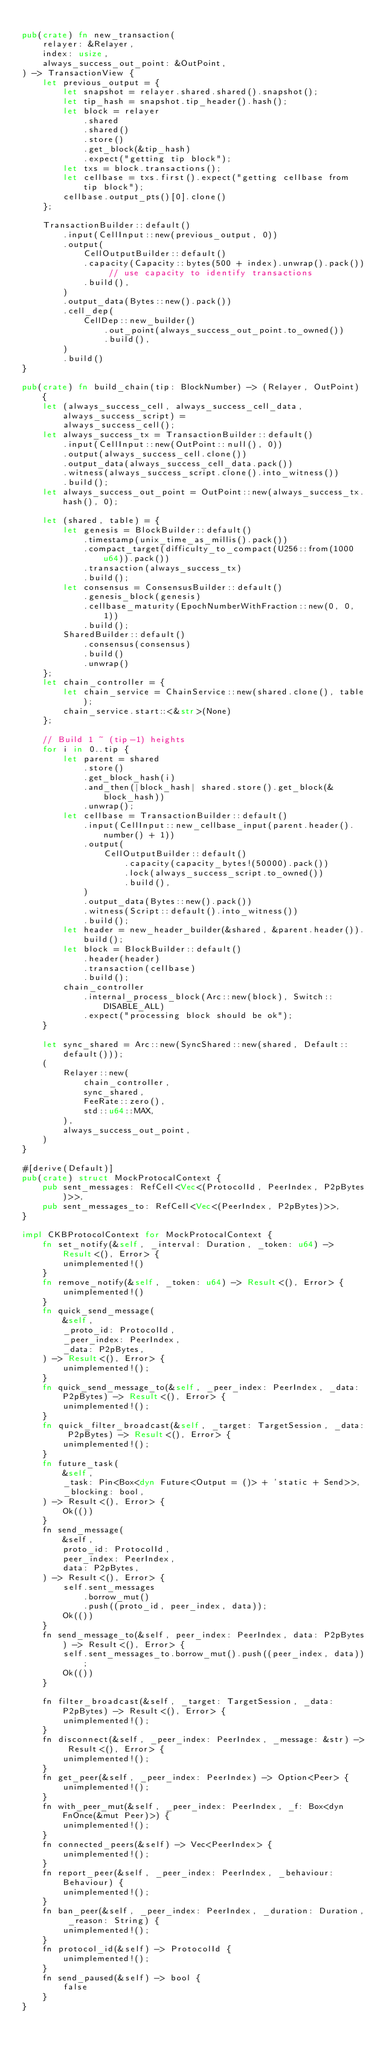<code> <loc_0><loc_0><loc_500><loc_500><_Rust_>
pub(crate) fn new_transaction(
    relayer: &Relayer,
    index: usize,
    always_success_out_point: &OutPoint,
) -> TransactionView {
    let previous_output = {
        let snapshot = relayer.shared.shared().snapshot();
        let tip_hash = snapshot.tip_header().hash();
        let block = relayer
            .shared
            .shared()
            .store()
            .get_block(&tip_hash)
            .expect("getting tip block");
        let txs = block.transactions();
        let cellbase = txs.first().expect("getting cellbase from tip block");
        cellbase.output_pts()[0].clone()
    };

    TransactionBuilder::default()
        .input(CellInput::new(previous_output, 0))
        .output(
            CellOutputBuilder::default()
            .capacity(Capacity::bytes(500 + index).unwrap().pack()) // use capacity to identify transactions
            .build(),
        )
        .output_data(Bytes::new().pack())
        .cell_dep(
            CellDep::new_builder()
                .out_point(always_success_out_point.to_owned())
                .build(),
        )
        .build()
}

pub(crate) fn build_chain(tip: BlockNumber) -> (Relayer, OutPoint) {
    let (always_success_cell, always_success_cell_data, always_success_script) =
        always_success_cell();
    let always_success_tx = TransactionBuilder::default()
        .input(CellInput::new(OutPoint::null(), 0))
        .output(always_success_cell.clone())
        .output_data(always_success_cell_data.pack())
        .witness(always_success_script.clone().into_witness())
        .build();
    let always_success_out_point = OutPoint::new(always_success_tx.hash(), 0);

    let (shared, table) = {
        let genesis = BlockBuilder::default()
            .timestamp(unix_time_as_millis().pack())
            .compact_target(difficulty_to_compact(U256::from(1000u64)).pack())
            .transaction(always_success_tx)
            .build();
        let consensus = ConsensusBuilder::default()
            .genesis_block(genesis)
            .cellbase_maturity(EpochNumberWithFraction::new(0, 0, 1))
            .build();
        SharedBuilder::default()
            .consensus(consensus)
            .build()
            .unwrap()
    };
    let chain_controller = {
        let chain_service = ChainService::new(shared.clone(), table);
        chain_service.start::<&str>(None)
    };

    // Build 1 ~ (tip-1) heights
    for i in 0..tip {
        let parent = shared
            .store()
            .get_block_hash(i)
            .and_then(|block_hash| shared.store().get_block(&block_hash))
            .unwrap();
        let cellbase = TransactionBuilder::default()
            .input(CellInput::new_cellbase_input(parent.header().number() + 1))
            .output(
                CellOutputBuilder::default()
                    .capacity(capacity_bytes!(50000).pack())
                    .lock(always_success_script.to_owned())
                    .build(),
            )
            .output_data(Bytes::new().pack())
            .witness(Script::default().into_witness())
            .build();
        let header = new_header_builder(&shared, &parent.header()).build();
        let block = BlockBuilder::default()
            .header(header)
            .transaction(cellbase)
            .build();
        chain_controller
            .internal_process_block(Arc::new(block), Switch::DISABLE_ALL)
            .expect("processing block should be ok");
    }

    let sync_shared = Arc::new(SyncShared::new(shared, Default::default()));
    (
        Relayer::new(
            chain_controller,
            sync_shared,
            FeeRate::zero(),
            std::u64::MAX,
        ),
        always_success_out_point,
    )
}

#[derive(Default)]
pub(crate) struct MockProtocalContext {
    pub sent_messages: RefCell<Vec<(ProtocolId, PeerIndex, P2pBytes)>>,
    pub sent_messages_to: RefCell<Vec<(PeerIndex, P2pBytes)>>,
}

impl CKBProtocolContext for MockProtocalContext {
    fn set_notify(&self, _interval: Duration, _token: u64) -> Result<(), Error> {
        unimplemented!()
    }
    fn remove_notify(&self, _token: u64) -> Result<(), Error> {
        unimplemented!()
    }
    fn quick_send_message(
        &self,
        _proto_id: ProtocolId,
        _peer_index: PeerIndex,
        _data: P2pBytes,
    ) -> Result<(), Error> {
        unimplemented!();
    }
    fn quick_send_message_to(&self, _peer_index: PeerIndex, _data: P2pBytes) -> Result<(), Error> {
        unimplemented!();
    }
    fn quick_filter_broadcast(&self, _target: TargetSession, _data: P2pBytes) -> Result<(), Error> {
        unimplemented!();
    }
    fn future_task(
        &self,
        _task: Pin<Box<dyn Future<Output = ()> + 'static + Send>>,
        _blocking: bool,
    ) -> Result<(), Error> {
        Ok(())
    }
    fn send_message(
        &self,
        proto_id: ProtocolId,
        peer_index: PeerIndex,
        data: P2pBytes,
    ) -> Result<(), Error> {
        self.sent_messages
            .borrow_mut()
            .push((proto_id, peer_index, data));
        Ok(())
    }
    fn send_message_to(&self, peer_index: PeerIndex, data: P2pBytes) -> Result<(), Error> {
        self.sent_messages_to.borrow_mut().push((peer_index, data));
        Ok(())
    }

    fn filter_broadcast(&self, _target: TargetSession, _data: P2pBytes) -> Result<(), Error> {
        unimplemented!();
    }
    fn disconnect(&self, _peer_index: PeerIndex, _message: &str) -> Result<(), Error> {
        unimplemented!();
    }
    fn get_peer(&self, _peer_index: PeerIndex) -> Option<Peer> {
        unimplemented!();
    }
    fn with_peer_mut(&self, _peer_index: PeerIndex, _f: Box<dyn FnOnce(&mut Peer)>) {
        unimplemented!();
    }
    fn connected_peers(&self) -> Vec<PeerIndex> {
        unimplemented!();
    }
    fn report_peer(&self, _peer_index: PeerIndex, _behaviour: Behaviour) {
        unimplemented!();
    }
    fn ban_peer(&self, _peer_index: PeerIndex, _duration: Duration, _reason: String) {
        unimplemented!();
    }
    fn protocol_id(&self) -> ProtocolId {
        unimplemented!();
    }
    fn send_paused(&self) -> bool {
        false
    }
}
</code> 